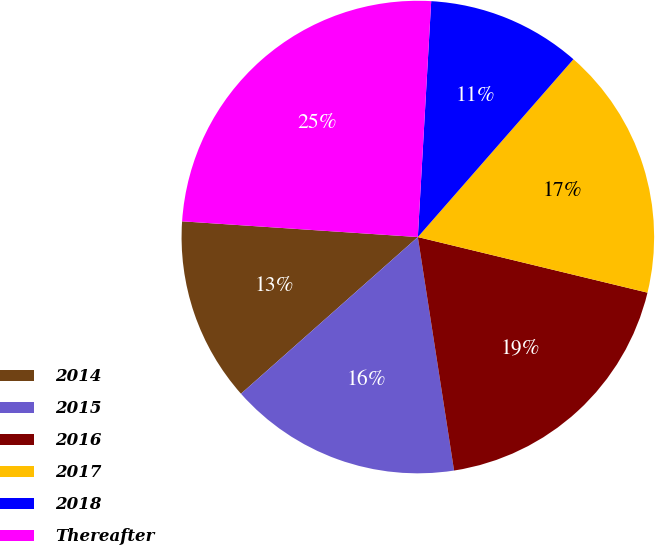Convert chart. <chart><loc_0><loc_0><loc_500><loc_500><pie_chart><fcel>2014<fcel>2015<fcel>2016<fcel>2017<fcel>2018<fcel>Thereafter<nl><fcel>12.6%<fcel>15.91%<fcel>18.77%<fcel>17.34%<fcel>10.54%<fcel>24.84%<nl></chart> 